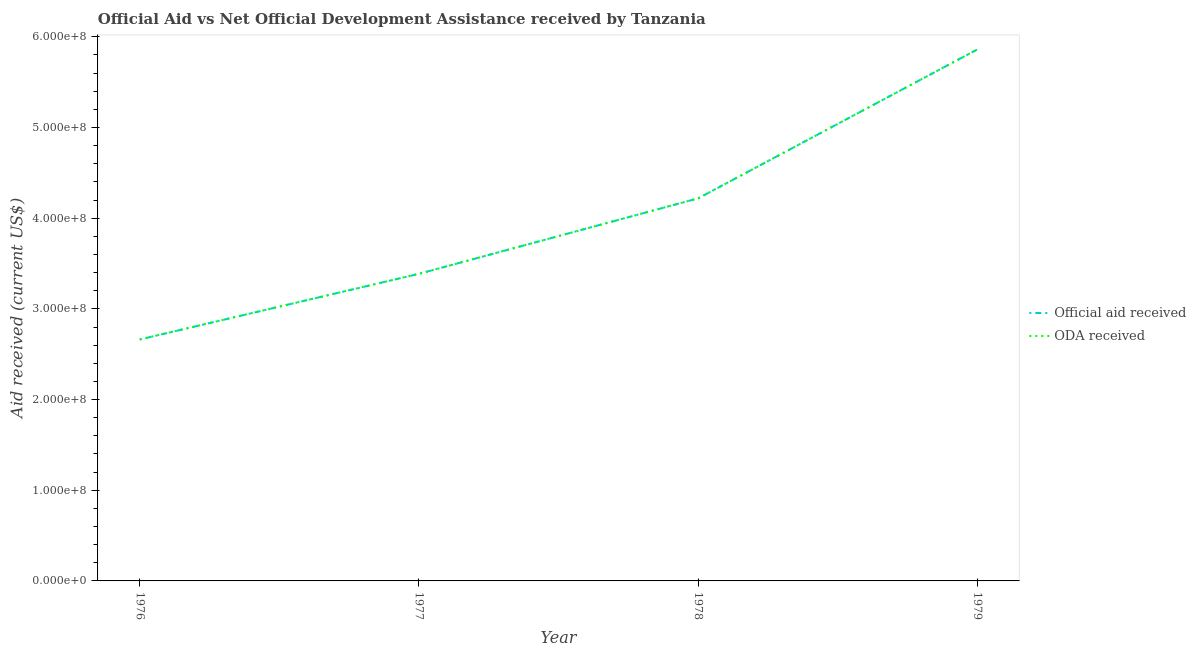Does the line corresponding to official aid received intersect with the line corresponding to oda received?
Keep it short and to the point. Yes. What is the official aid received in 1977?
Offer a terse response. 3.39e+08. Across all years, what is the maximum official aid received?
Offer a very short reply. 5.86e+08. Across all years, what is the minimum official aid received?
Your response must be concise. 2.66e+08. In which year was the oda received maximum?
Offer a very short reply. 1979. In which year was the oda received minimum?
Your response must be concise. 1976. What is the total oda received in the graph?
Give a very brief answer. 1.61e+09. What is the difference between the official aid received in 1978 and that in 1979?
Give a very brief answer. -1.64e+08. What is the difference between the official aid received in 1976 and the oda received in 1977?
Provide a short and direct response. -7.24e+07. What is the average official aid received per year?
Keep it short and to the point. 4.03e+08. What is the ratio of the official aid received in 1977 to that in 1978?
Provide a short and direct response. 0.8. Is the official aid received in 1977 less than that in 1978?
Make the answer very short. Yes. What is the difference between the highest and the second highest oda received?
Provide a short and direct response. 1.64e+08. What is the difference between the highest and the lowest official aid received?
Provide a short and direct response. 3.20e+08. In how many years, is the official aid received greater than the average official aid received taken over all years?
Ensure brevity in your answer.  2. Is the sum of the official aid received in 1977 and 1978 greater than the maximum oda received across all years?
Provide a succinct answer. Yes. Is the official aid received strictly greater than the oda received over the years?
Ensure brevity in your answer.  No. Is the oda received strictly less than the official aid received over the years?
Give a very brief answer. No. How many lines are there?
Your response must be concise. 2. What is the difference between two consecutive major ticks on the Y-axis?
Offer a very short reply. 1.00e+08. Are the values on the major ticks of Y-axis written in scientific E-notation?
Keep it short and to the point. Yes. Where does the legend appear in the graph?
Your response must be concise. Center right. How many legend labels are there?
Keep it short and to the point. 2. How are the legend labels stacked?
Give a very brief answer. Vertical. What is the title of the graph?
Your answer should be very brief. Official Aid vs Net Official Development Assistance received by Tanzania . What is the label or title of the X-axis?
Make the answer very short. Year. What is the label or title of the Y-axis?
Provide a succinct answer. Aid received (current US$). What is the Aid received (current US$) of Official aid received in 1976?
Your answer should be very brief. 2.66e+08. What is the Aid received (current US$) in ODA received in 1976?
Your answer should be compact. 2.66e+08. What is the Aid received (current US$) of Official aid received in 1977?
Provide a succinct answer. 3.39e+08. What is the Aid received (current US$) of ODA received in 1977?
Your response must be concise. 3.39e+08. What is the Aid received (current US$) in Official aid received in 1978?
Provide a short and direct response. 4.22e+08. What is the Aid received (current US$) in ODA received in 1978?
Give a very brief answer. 4.22e+08. What is the Aid received (current US$) in Official aid received in 1979?
Your answer should be very brief. 5.86e+08. What is the Aid received (current US$) of ODA received in 1979?
Your answer should be compact. 5.86e+08. Across all years, what is the maximum Aid received (current US$) in Official aid received?
Keep it short and to the point. 5.86e+08. Across all years, what is the maximum Aid received (current US$) in ODA received?
Your response must be concise. 5.86e+08. Across all years, what is the minimum Aid received (current US$) in Official aid received?
Keep it short and to the point. 2.66e+08. Across all years, what is the minimum Aid received (current US$) of ODA received?
Offer a very short reply. 2.66e+08. What is the total Aid received (current US$) of Official aid received in the graph?
Provide a short and direct response. 1.61e+09. What is the total Aid received (current US$) in ODA received in the graph?
Your answer should be very brief. 1.61e+09. What is the difference between the Aid received (current US$) in Official aid received in 1976 and that in 1977?
Provide a short and direct response. -7.24e+07. What is the difference between the Aid received (current US$) of ODA received in 1976 and that in 1977?
Your answer should be compact. -7.24e+07. What is the difference between the Aid received (current US$) of Official aid received in 1976 and that in 1978?
Offer a terse response. -1.56e+08. What is the difference between the Aid received (current US$) in ODA received in 1976 and that in 1978?
Provide a succinct answer. -1.56e+08. What is the difference between the Aid received (current US$) in Official aid received in 1976 and that in 1979?
Your response must be concise. -3.20e+08. What is the difference between the Aid received (current US$) of ODA received in 1976 and that in 1979?
Your answer should be very brief. -3.20e+08. What is the difference between the Aid received (current US$) in Official aid received in 1977 and that in 1978?
Your answer should be very brief. -8.32e+07. What is the difference between the Aid received (current US$) of ODA received in 1977 and that in 1978?
Your response must be concise. -8.32e+07. What is the difference between the Aid received (current US$) of Official aid received in 1977 and that in 1979?
Ensure brevity in your answer.  -2.47e+08. What is the difference between the Aid received (current US$) in ODA received in 1977 and that in 1979?
Make the answer very short. -2.47e+08. What is the difference between the Aid received (current US$) of Official aid received in 1978 and that in 1979?
Offer a terse response. -1.64e+08. What is the difference between the Aid received (current US$) in ODA received in 1978 and that in 1979?
Make the answer very short. -1.64e+08. What is the difference between the Aid received (current US$) of Official aid received in 1976 and the Aid received (current US$) of ODA received in 1977?
Offer a terse response. -7.24e+07. What is the difference between the Aid received (current US$) in Official aid received in 1976 and the Aid received (current US$) in ODA received in 1978?
Offer a very short reply. -1.56e+08. What is the difference between the Aid received (current US$) in Official aid received in 1976 and the Aid received (current US$) in ODA received in 1979?
Keep it short and to the point. -3.20e+08. What is the difference between the Aid received (current US$) of Official aid received in 1977 and the Aid received (current US$) of ODA received in 1978?
Ensure brevity in your answer.  -8.32e+07. What is the difference between the Aid received (current US$) in Official aid received in 1977 and the Aid received (current US$) in ODA received in 1979?
Make the answer very short. -2.47e+08. What is the difference between the Aid received (current US$) of Official aid received in 1978 and the Aid received (current US$) of ODA received in 1979?
Your answer should be compact. -1.64e+08. What is the average Aid received (current US$) in Official aid received per year?
Offer a very short reply. 4.03e+08. What is the average Aid received (current US$) of ODA received per year?
Ensure brevity in your answer.  4.03e+08. In the year 1978, what is the difference between the Aid received (current US$) in Official aid received and Aid received (current US$) in ODA received?
Provide a short and direct response. 0. In the year 1979, what is the difference between the Aid received (current US$) in Official aid received and Aid received (current US$) in ODA received?
Your answer should be very brief. 0. What is the ratio of the Aid received (current US$) in Official aid received in 1976 to that in 1977?
Your response must be concise. 0.79. What is the ratio of the Aid received (current US$) in ODA received in 1976 to that in 1977?
Offer a very short reply. 0.79. What is the ratio of the Aid received (current US$) of Official aid received in 1976 to that in 1978?
Make the answer very short. 0.63. What is the ratio of the Aid received (current US$) of ODA received in 1976 to that in 1978?
Your answer should be very brief. 0.63. What is the ratio of the Aid received (current US$) of Official aid received in 1976 to that in 1979?
Provide a short and direct response. 0.45. What is the ratio of the Aid received (current US$) of ODA received in 1976 to that in 1979?
Ensure brevity in your answer.  0.45. What is the ratio of the Aid received (current US$) in Official aid received in 1977 to that in 1978?
Ensure brevity in your answer.  0.8. What is the ratio of the Aid received (current US$) of ODA received in 1977 to that in 1978?
Your answer should be very brief. 0.8. What is the ratio of the Aid received (current US$) in Official aid received in 1977 to that in 1979?
Give a very brief answer. 0.58. What is the ratio of the Aid received (current US$) in ODA received in 1977 to that in 1979?
Give a very brief answer. 0.58. What is the ratio of the Aid received (current US$) in Official aid received in 1978 to that in 1979?
Your answer should be compact. 0.72. What is the ratio of the Aid received (current US$) in ODA received in 1978 to that in 1979?
Offer a very short reply. 0.72. What is the difference between the highest and the second highest Aid received (current US$) in Official aid received?
Offer a terse response. 1.64e+08. What is the difference between the highest and the second highest Aid received (current US$) in ODA received?
Offer a terse response. 1.64e+08. What is the difference between the highest and the lowest Aid received (current US$) of Official aid received?
Keep it short and to the point. 3.20e+08. What is the difference between the highest and the lowest Aid received (current US$) in ODA received?
Keep it short and to the point. 3.20e+08. 